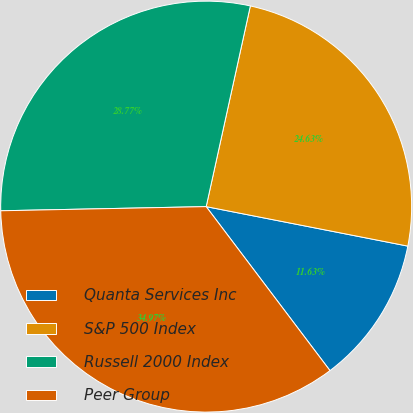Convert chart. <chart><loc_0><loc_0><loc_500><loc_500><pie_chart><fcel>Quanta Services Inc<fcel>S&P 500 Index<fcel>Russell 2000 Index<fcel>Peer Group<nl><fcel>11.63%<fcel>24.63%<fcel>28.77%<fcel>34.97%<nl></chart> 